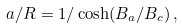Convert formula to latex. <formula><loc_0><loc_0><loc_500><loc_500>a / R = 1 / \cosh ( B _ { a } / B _ { c } ) \, ,</formula> 